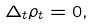<formula> <loc_0><loc_0><loc_500><loc_500>\Delta _ { t } \rho _ { t } = 0 ,</formula> 